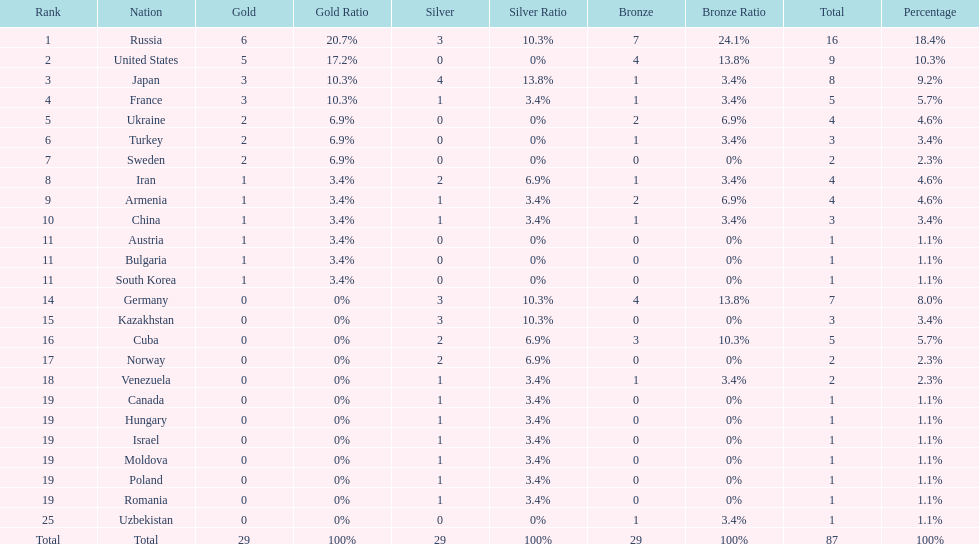What is the total amount of nations with more than 5 bronze medals? 1. 